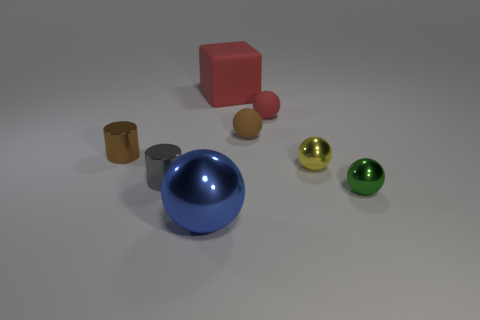There is a blue thing that is the same material as the small gray cylinder; what is its size?
Offer a terse response. Large. What size is the green thing that is the same shape as the blue object?
Keep it short and to the point. Small. Are there any brown objects?
Your answer should be compact. Yes. How many objects are either objects that are in front of the brown metal cylinder or brown shiny cylinders?
Provide a succinct answer. 5. What material is the red object that is the same size as the gray cylinder?
Keep it short and to the point. Rubber. The small rubber ball that is on the left side of the red rubber thing that is in front of the big rubber object is what color?
Your response must be concise. Brown. What number of brown metal objects are to the right of the tiny gray object?
Your answer should be compact. 0. The rubber block has what color?
Give a very brief answer. Red. How many big things are either gray rubber objects or brown rubber spheres?
Give a very brief answer. 0. Do the large thing right of the blue metallic object and the small rubber ball behind the tiny brown rubber object have the same color?
Make the answer very short. Yes. 